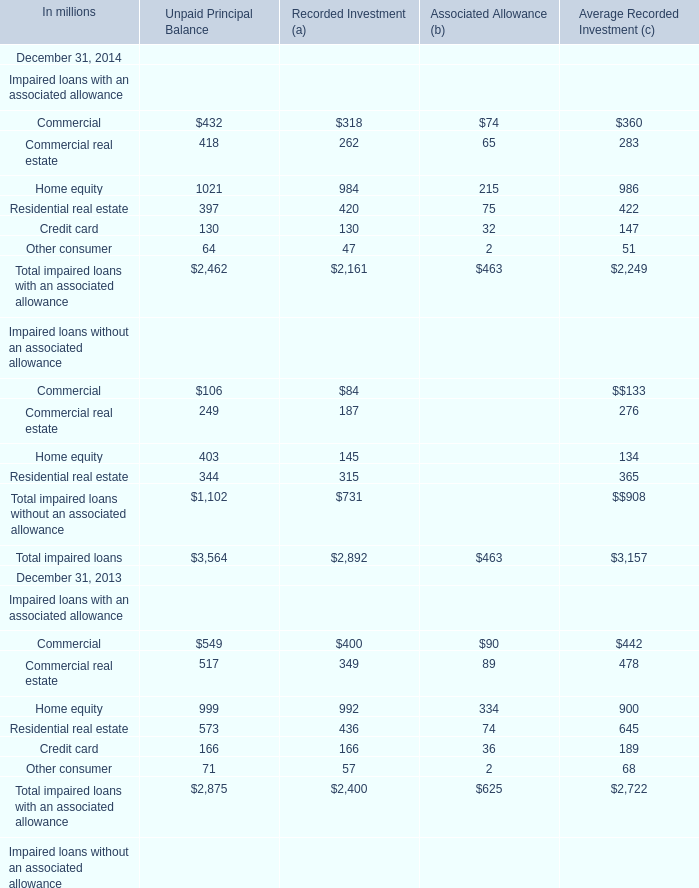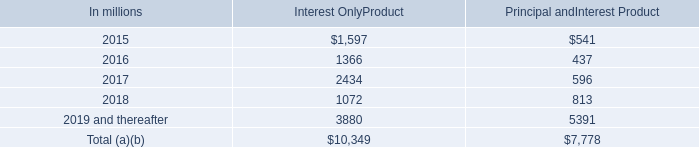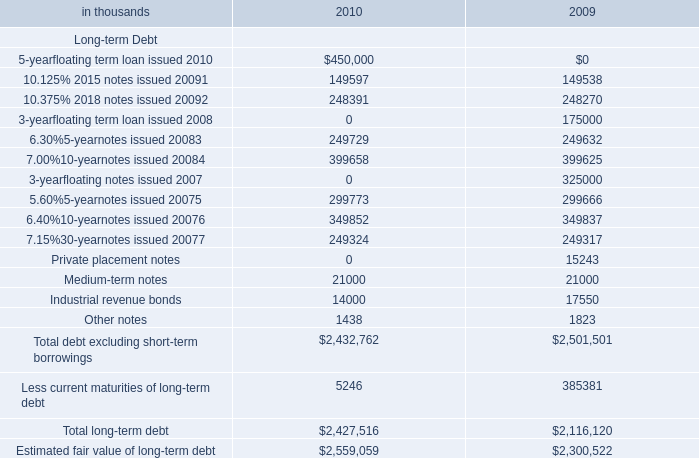Total impaired loans with an associated allowance for Recorded Investment (a) on December 31 in which year ranks first? 
Answer: 2013. 